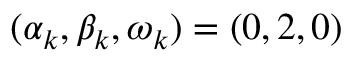Convert formula to latex. <formula><loc_0><loc_0><loc_500><loc_500>( \alpha _ { k } , \beta _ { k } , \omega _ { k } ) = ( 0 , 2 , 0 )</formula> 